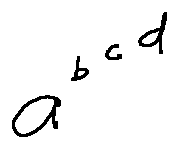Convert formula to latex. <formula><loc_0><loc_0><loc_500><loc_500>a ^ { b ^ { c ^ { d } } }</formula> 